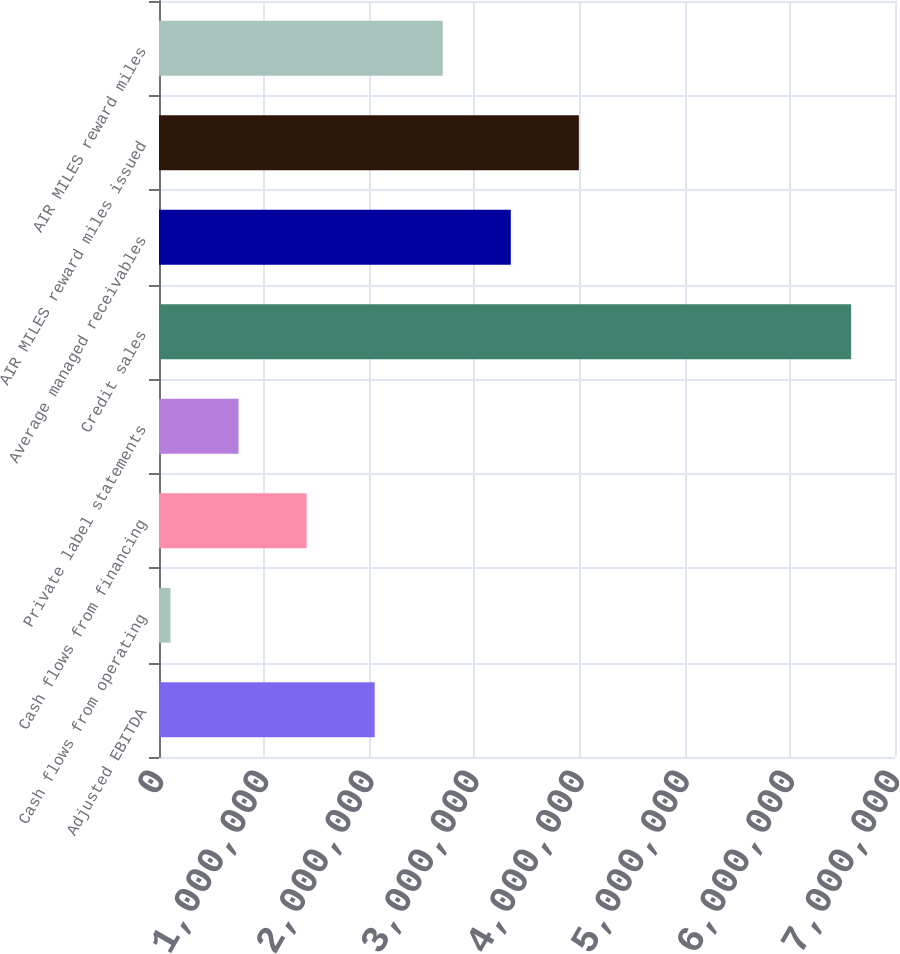Convert chart. <chart><loc_0><loc_0><loc_500><loc_500><bar_chart><fcel>Adjusted EBITDA<fcel>Cash flows from operating<fcel>Cash flows from financing<fcel>Private label statements<fcel>Credit sales<fcel>Average managed receivables<fcel>AIR MILES reward miles issued<fcel>AIR MILES reward miles<nl><fcel>2.0512e+06<fcel>109081<fcel>1.40382e+06<fcel>756453<fcel>6.5828e+06<fcel>3.34594e+06<fcel>3.99331e+06<fcel>2.69857e+06<nl></chart> 